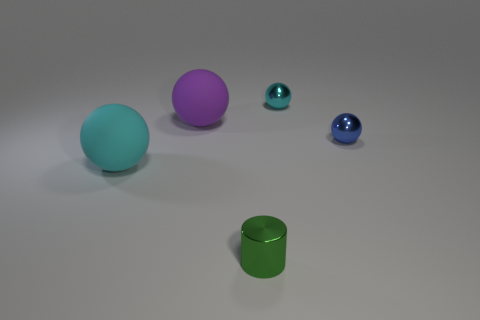Is the size of the cyan rubber ball the same as the green object?
Make the answer very short. No. What size is the sphere that is to the right of the cyan ball that is on the right side of the tiny green thing?
Your answer should be very brief. Small. Are there any green spheres that have the same size as the blue shiny ball?
Ensure brevity in your answer.  No. There is a cyan ball that is behind the big cyan matte ball; how big is it?
Your response must be concise. Small. There is a large matte ball that is behind the large cyan thing; is there a metallic sphere that is in front of it?
Offer a very short reply. Yes. What number of other objects are the same shape as the small cyan shiny object?
Ensure brevity in your answer.  3. Is the big purple rubber object the same shape as the small cyan metal thing?
Your answer should be very brief. Yes. There is a sphere that is behind the blue shiny object and to the left of the cyan metal sphere; what is its color?
Provide a succinct answer. Purple. What number of large objects are brown blocks or cylinders?
Provide a short and direct response. 0. Are there any other things of the same color as the small metal cylinder?
Offer a terse response. No. 